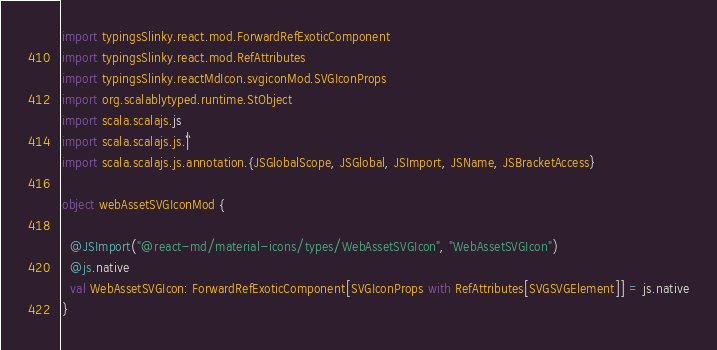Convert code to text. <code><loc_0><loc_0><loc_500><loc_500><_Scala_>import typingsSlinky.react.mod.ForwardRefExoticComponent
import typingsSlinky.react.mod.RefAttributes
import typingsSlinky.reactMdIcon.svgiconMod.SVGIconProps
import org.scalablytyped.runtime.StObject
import scala.scalajs.js
import scala.scalajs.js.`|`
import scala.scalajs.js.annotation.{JSGlobalScope, JSGlobal, JSImport, JSName, JSBracketAccess}

object webAssetSVGIconMod {
  
  @JSImport("@react-md/material-icons/types/WebAssetSVGIcon", "WebAssetSVGIcon")
  @js.native
  val WebAssetSVGIcon: ForwardRefExoticComponent[SVGIconProps with RefAttributes[SVGSVGElement]] = js.native
}
</code> 